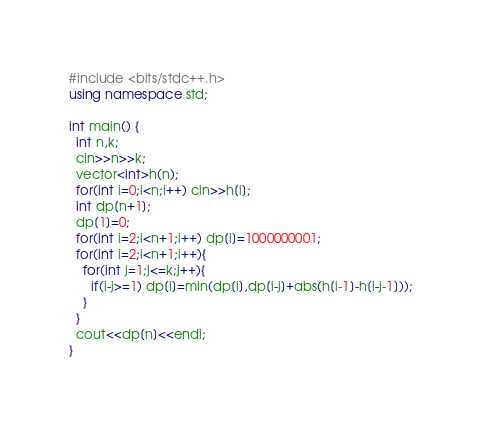Convert code to text. <code><loc_0><loc_0><loc_500><loc_500><_C++_>#include <bits/stdc++.h>
using namespace std;

int main() {
  int n,k;
  cin>>n>>k;
  vector<int>h(n);
  for(int i=0;i<n;i++) cin>>h[i];
  int dp[n+1];
  dp[1]=0;
  for(int i=2;i<n+1;i++) dp[i]=1000000001;
  for(int i=2;i<n+1;i++){
    for(int j=1;j<=k;j++){
      if(i-j>=1) dp[i]=min(dp[i],dp[i-j]+abs(h[i-1]-h[i-j-1]));
    }
  }
  cout<<dp[n]<<endl;
}</code> 